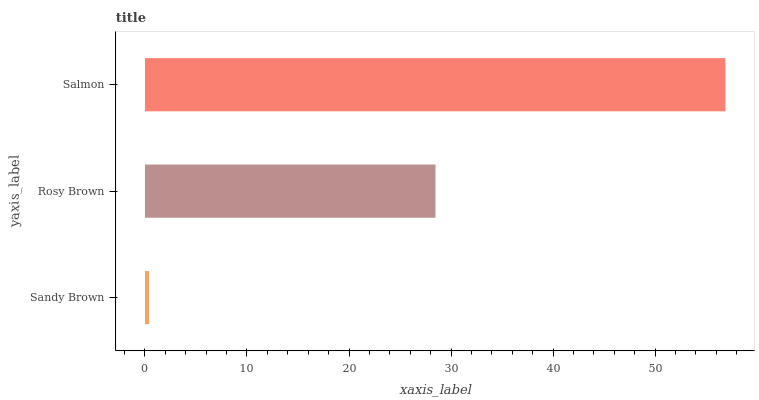Is Sandy Brown the minimum?
Answer yes or no. Yes. Is Salmon the maximum?
Answer yes or no. Yes. Is Rosy Brown the minimum?
Answer yes or no. No. Is Rosy Brown the maximum?
Answer yes or no. No. Is Rosy Brown greater than Sandy Brown?
Answer yes or no. Yes. Is Sandy Brown less than Rosy Brown?
Answer yes or no. Yes. Is Sandy Brown greater than Rosy Brown?
Answer yes or no. No. Is Rosy Brown less than Sandy Brown?
Answer yes or no. No. Is Rosy Brown the high median?
Answer yes or no. Yes. Is Rosy Brown the low median?
Answer yes or no. Yes. Is Sandy Brown the high median?
Answer yes or no. No. Is Sandy Brown the low median?
Answer yes or no. No. 